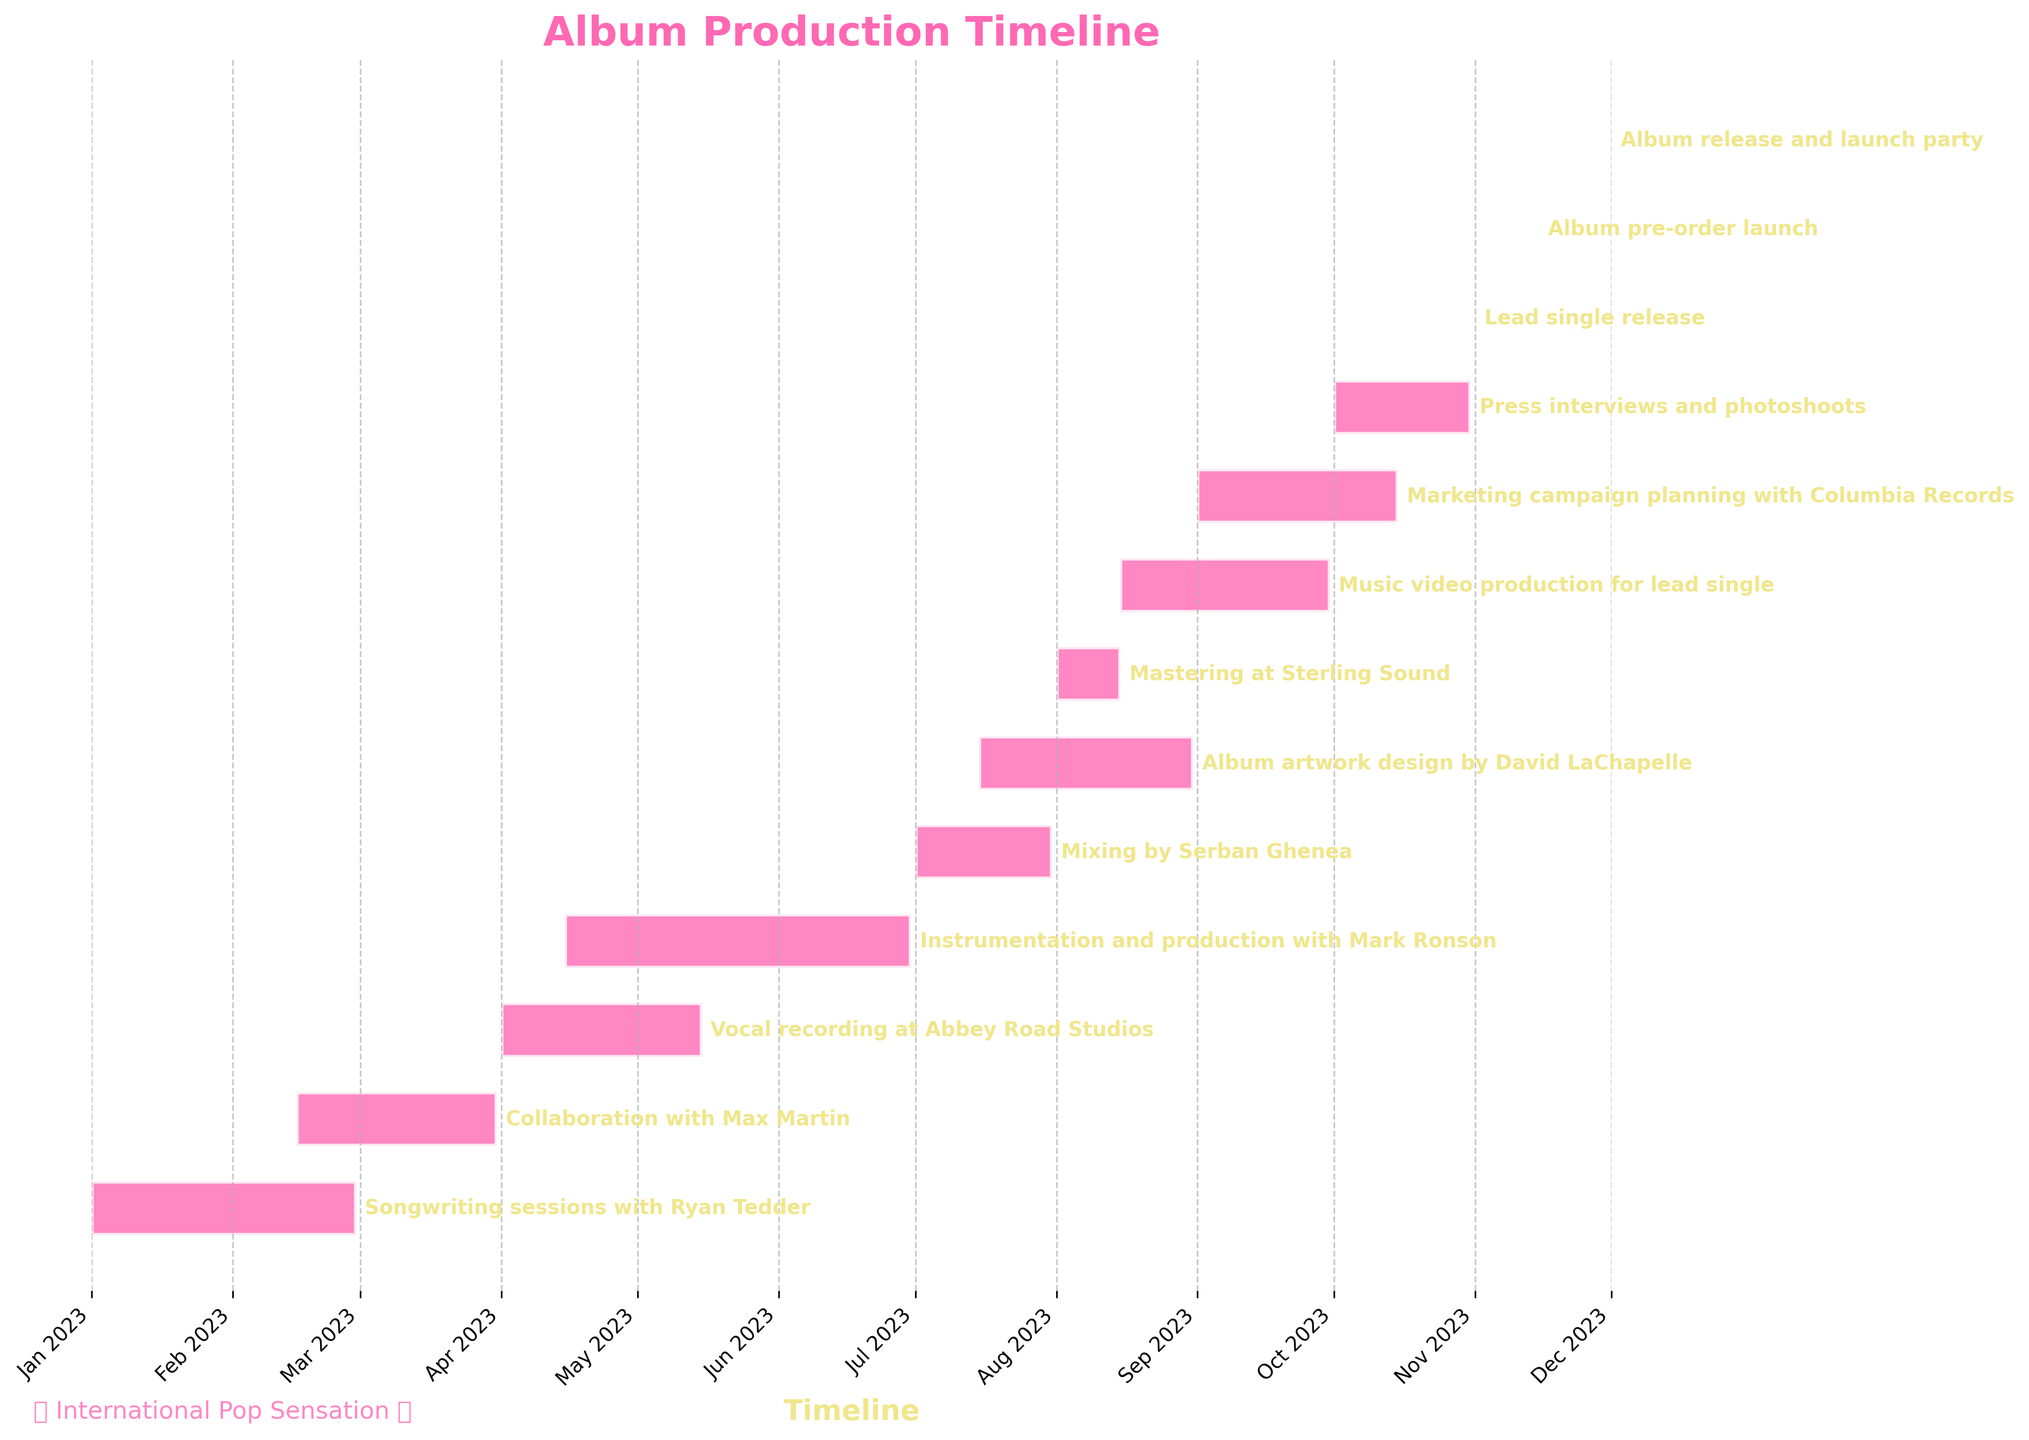What is the title of the chart? The title of the chart is prominently displayed at the top of the figure and can be directly read.
Answer: Album Production Timeline When did the vocal recording at Abbey Road Studios start and end? Refer to the task labeled "Vocal recording at Abbey Road Studios" and observe the start and end dates on the horizontal timeline.
Answer: April 1, 2023 to May 15, 2023 Which task has the shortest duration? Check the duration of each task by observing the length of the horizontal bars. The task with the shortest bar corresponds to the shortest duration.
Answer: Lead single release, Album pre-order launch, and Album release and launch party How many tasks are scheduled for 2023? Count the number of task bars starting or ending within the specified year on the x-axis.
Answer: 12 Which tasks overlap with "Collaboration with Max Martin"? Identify the duration of "Collaboration with Max Martin" and check which other tasks' bars overlap with this period on the timeline.
Answer: Songwriting sessions with Ryan Tedder, Vocal recording at Abbey Road Studios Do "Mixing by Serban Ghenea" and "Mastering at Sterling Sound" occur consecutively? Observe the end date of "Mixing by Serban Ghenea" and the start date of "Mastering at Sterling Sound" to see if there's a direct transition without a time gap.
Answer: Yes What are the tasks occurring in June 2023? Identify the tasks whose bars encompass or intersect the month of June 2023 on the x-axis.
Answer: Instrumentation and production with Mark Ronson Which phase marks the start of the final quarter of production? Look at the chronological order of tasks and identify which task starts in the final quarter of the year (October to December).
Answer: Press interviews and photoshoots When do the songwriting sessions with Ryan Tedder end? Check the end date of the task labeled "Songwriting sessions with Ryan Tedder" on the timeline.
Answer: February 28, 2023 Which task requires the coordination of the most professionals? The question requires a logical synthesis by considering the number of individuals mentioned for each task in the given data.
Answer: Instrumentation and production with Mark Ronson 